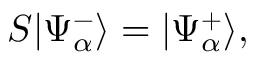Convert formula to latex. <formula><loc_0><loc_0><loc_500><loc_500>S | \Psi _ { \alpha } ^ { - } \rangle = | \Psi _ { \alpha } ^ { + } \rangle ,</formula> 